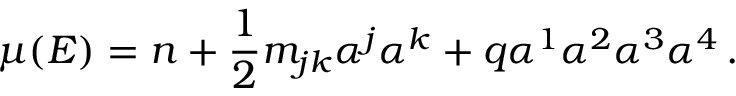Convert formula to latex. <formula><loc_0><loc_0><loc_500><loc_500>\mu ( E ) = n + \frac { 1 } { 2 } m _ { j k } \alpha ^ { j } \alpha ^ { k } + q \alpha ^ { 1 } \alpha ^ { 2 } \alpha ^ { 3 } \alpha ^ { 4 } \, .</formula> 